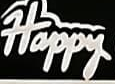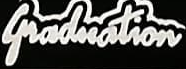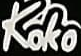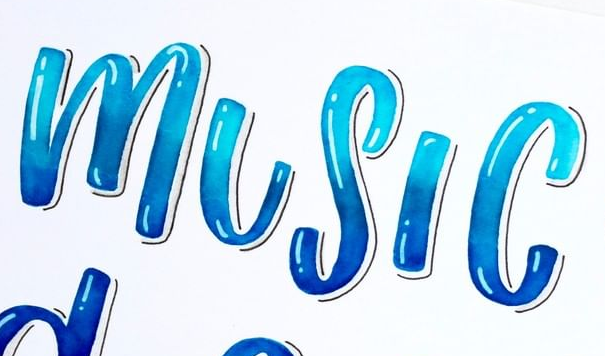What text is displayed in these images sequentially, separated by a semicolon? Happy; Graduation; Koko; MUSIC 